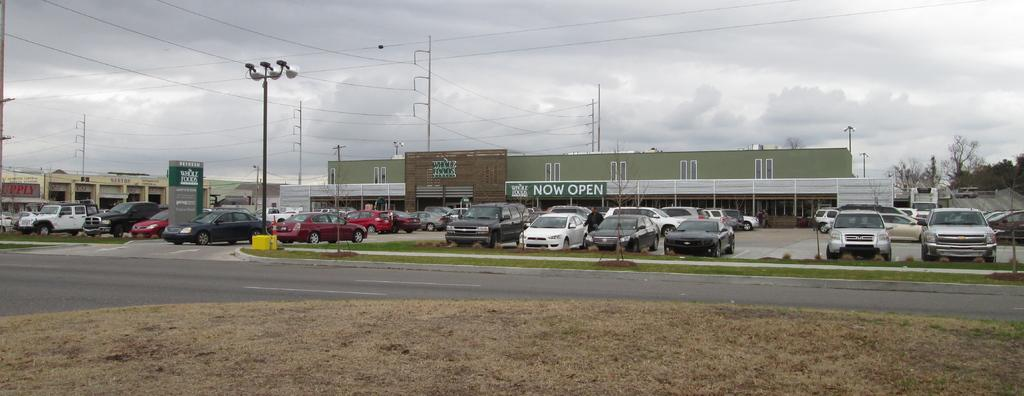Provide a one-sentence caption for the provided image. A Whole Foods parking lot has several cars parked in it. 